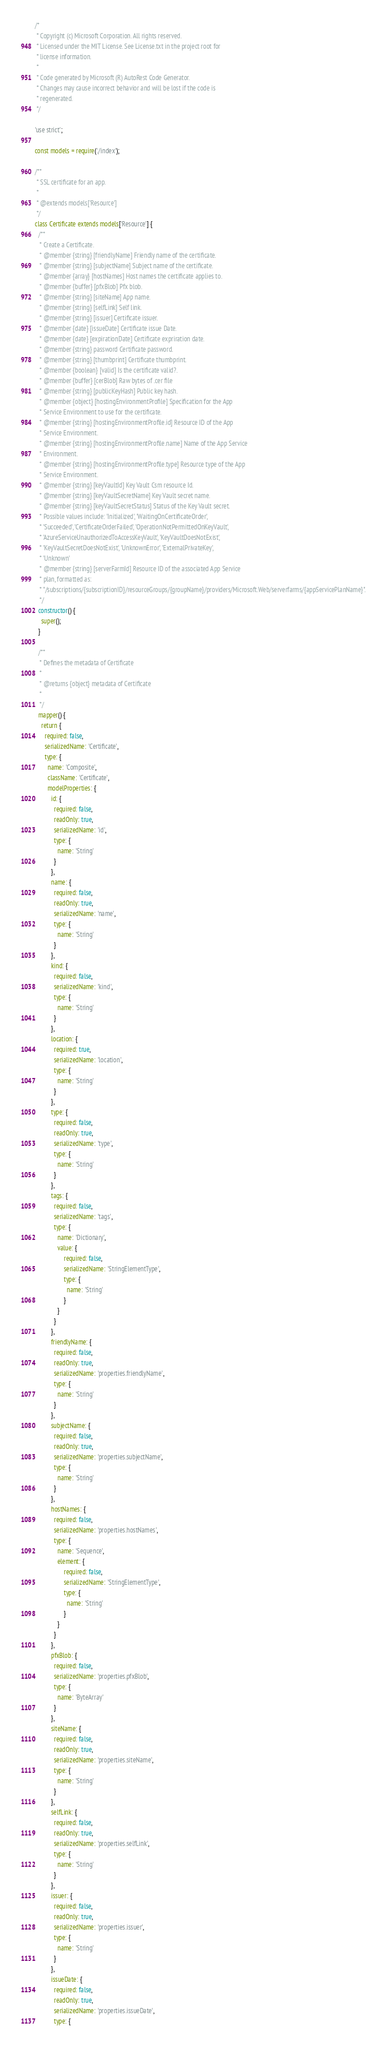Convert code to text. <code><loc_0><loc_0><loc_500><loc_500><_JavaScript_>/*
 * Copyright (c) Microsoft Corporation. All rights reserved.
 * Licensed under the MIT License. See License.txt in the project root for
 * license information.
 *
 * Code generated by Microsoft (R) AutoRest Code Generator.
 * Changes may cause incorrect behavior and will be lost if the code is
 * regenerated.
 */

'use strict';

const models = require('./index');

/**
 * SSL certificate for an app.
 *
 * @extends models['Resource']
 */
class Certificate extends models['Resource'] {
  /**
   * Create a Certificate.
   * @member {string} [friendlyName] Friendly name of the certificate.
   * @member {string} [subjectName] Subject name of the certificate.
   * @member {array} [hostNames] Host names the certificate applies to.
   * @member {buffer} [pfxBlob] Pfx blob.
   * @member {string} [siteName] App name.
   * @member {string} [selfLink] Self link.
   * @member {string} [issuer] Certificate issuer.
   * @member {date} [issueDate] Certificate issue Date.
   * @member {date} [expirationDate] Certificate expriration date.
   * @member {string} password Certificate password.
   * @member {string} [thumbprint] Certificate thumbprint.
   * @member {boolean} [valid] Is the certificate valid?.
   * @member {buffer} [cerBlob] Raw bytes of .cer file
   * @member {string} [publicKeyHash] Public key hash.
   * @member {object} [hostingEnvironmentProfile] Specification for the App
   * Service Environment to use for the certificate.
   * @member {string} [hostingEnvironmentProfile.id] Resource ID of the App
   * Service Environment.
   * @member {string} [hostingEnvironmentProfile.name] Name of the App Service
   * Environment.
   * @member {string} [hostingEnvironmentProfile.type] Resource type of the App
   * Service Environment.
   * @member {string} [keyVaultId] Key Vault Csm resource Id.
   * @member {string} [keyVaultSecretName] Key Vault secret name.
   * @member {string} [keyVaultSecretStatus] Status of the Key Vault secret.
   * Possible values include: 'Initialized', 'WaitingOnCertificateOrder',
   * 'Succeeded', 'CertificateOrderFailed', 'OperationNotPermittedOnKeyVault',
   * 'AzureServiceUnauthorizedToAccessKeyVault', 'KeyVaultDoesNotExist',
   * 'KeyVaultSecretDoesNotExist', 'UnknownError', 'ExternalPrivateKey',
   * 'Unknown'
   * @member {string} [serverFarmId] Resource ID of the associated App Service
   * plan, formatted as:
   * "/subscriptions/{subscriptionID}/resourceGroups/{groupName}/providers/Microsoft.Web/serverfarms/{appServicePlanName}".
   */
  constructor() {
    super();
  }

  /**
   * Defines the metadata of Certificate
   *
   * @returns {object} metadata of Certificate
   *
   */
  mapper() {
    return {
      required: false,
      serializedName: 'Certificate',
      type: {
        name: 'Composite',
        className: 'Certificate',
        modelProperties: {
          id: {
            required: false,
            readOnly: true,
            serializedName: 'id',
            type: {
              name: 'String'
            }
          },
          name: {
            required: false,
            readOnly: true,
            serializedName: 'name',
            type: {
              name: 'String'
            }
          },
          kind: {
            required: false,
            serializedName: 'kind',
            type: {
              name: 'String'
            }
          },
          location: {
            required: true,
            serializedName: 'location',
            type: {
              name: 'String'
            }
          },
          type: {
            required: false,
            readOnly: true,
            serializedName: 'type',
            type: {
              name: 'String'
            }
          },
          tags: {
            required: false,
            serializedName: 'tags',
            type: {
              name: 'Dictionary',
              value: {
                  required: false,
                  serializedName: 'StringElementType',
                  type: {
                    name: 'String'
                  }
              }
            }
          },
          friendlyName: {
            required: false,
            readOnly: true,
            serializedName: 'properties.friendlyName',
            type: {
              name: 'String'
            }
          },
          subjectName: {
            required: false,
            readOnly: true,
            serializedName: 'properties.subjectName',
            type: {
              name: 'String'
            }
          },
          hostNames: {
            required: false,
            serializedName: 'properties.hostNames',
            type: {
              name: 'Sequence',
              element: {
                  required: false,
                  serializedName: 'StringElementType',
                  type: {
                    name: 'String'
                  }
              }
            }
          },
          pfxBlob: {
            required: false,
            serializedName: 'properties.pfxBlob',
            type: {
              name: 'ByteArray'
            }
          },
          siteName: {
            required: false,
            readOnly: true,
            serializedName: 'properties.siteName',
            type: {
              name: 'String'
            }
          },
          selfLink: {
            required: false,
            readOnly: true,
            serializedName: 'properties.selfLink',
            type: {
              name: 'String'
            }
          },
          issuer: {
            required: false,
            readOnly: true,
            serializedName: 'properties.issuer',
            type: {
              name: 'String'
            }
          },
          issueDate: {
            required: false,
            readOnly: true,
            serializedName: 'properties.issueDate',
            type: {</code> 